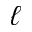Convert formula to latex. <formula><loc_0><loc_0><loc_500><loc_500>\ell</formula> 